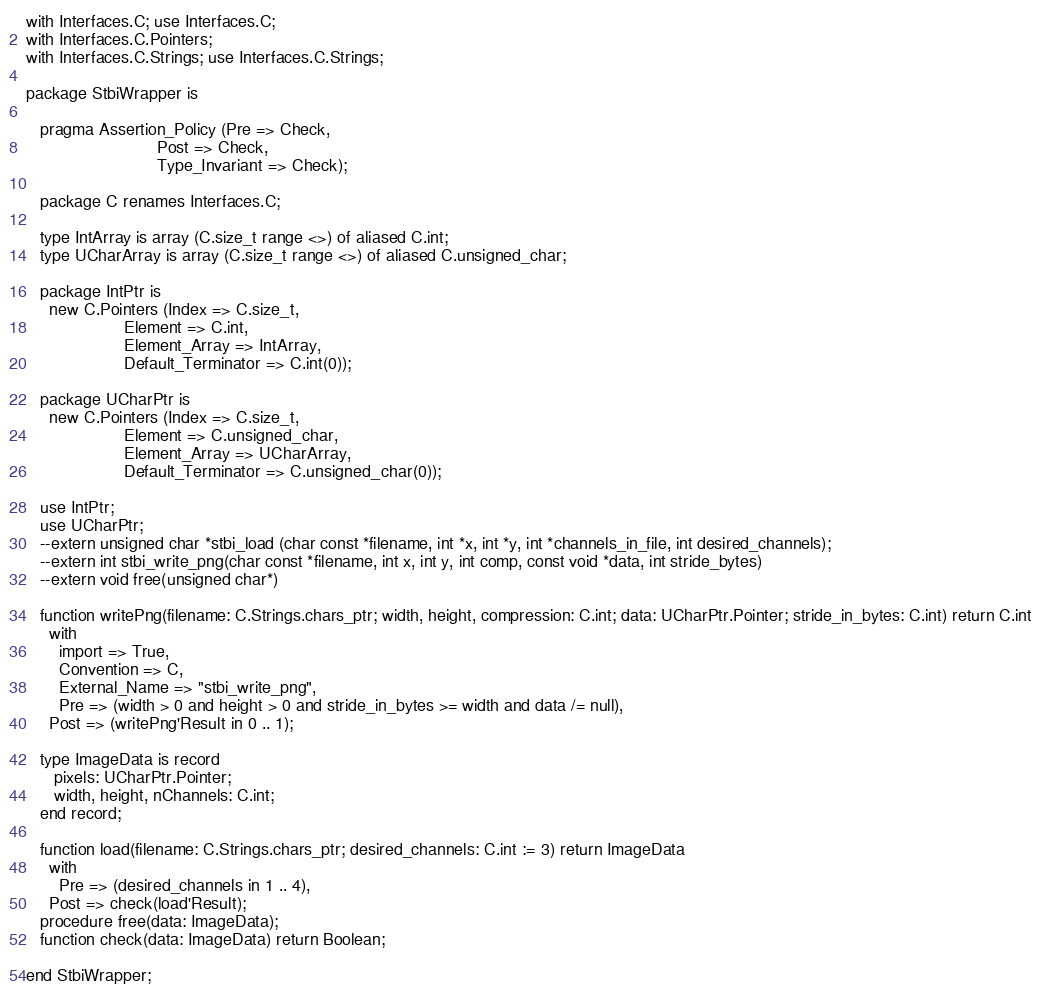Convert code to text. <code><loc_0><loc_0><loc_500><loc_500><_Ada_>with Interfaces.C; use Interfaces.C;
with Interfaces.C.Pointers;
with Interfaces.C.Strings; use Interfaces.C.Strings;

package StbiWrapper is

   pragma Assertion_Policy (Pre => Check,
                            Post => Check,
                            Type_Invariant => Check);

   package C renames Interfaces.C;

   type IntArray is array (C.size_t range <>) of aliased C.int;
   type UCharArray is array (C.size_t range <>) of aliased C.unsigned_char;

   package IntPtr is
     new C.Pointers (Index => C.size_t,
                     Element => C.int,
                     Element_Array => IntArray,
                     Default_Terminator => C.int(0));

   package UCharPtr is
     new C.Pointers (Index => C.size_t,
                     Element => C.unsigned_char,
                     Element_Array => UCharArray,
                     Default_Terminator => C.unsigned_char(0));

   use IntPtr;
   use UCharPtr;
   --extern unsigned char *stbi_load (char const *filename, int *x, int *y, int *channels_in_file, int desired_channels);
   --extern int stbi_write_png(char const *filename, int x, int y, int comp, const void *data, int stride_bytes)
   --extern void free(unsigned char*)

   function writePng(filename: C.Strings.chars_ptr; width, height, compression: C.int; data: UCharPtr.Pointer; stride_in_bytes: C.int) return C.int
     with
       import => True,
       Convention => C,
       External_Name => "stbi_write_png",
       Pre => (width > 0 and height > 0 and stride_in_bytes >= width and data /= null),
     Post => (writePng'Result in 0 .. 1);

   type ImageData is record
      pixels: UCharPtr.Pointer;
      width, height, nChannels: C.int;
   end record;

   function load(filename: C.Strings.chars_ptr; desired_channels: C.int := 3) return ImageData
     with
       Pre => (desired_channels in 1 .. 4),
     Post => check(load'Result);
   procedure free(data: ImageData);
   function check(data: ImageData) return Boolean;

end StbiWrapper;
</code> 